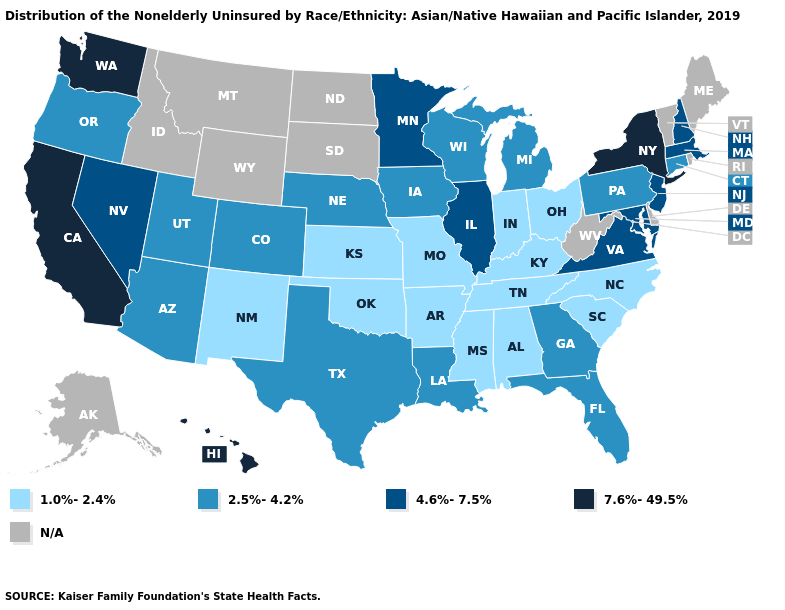Which states have the lowest value in the USA?
Concise answer only. Alabama, Arkansas, Indiana, Kansas, Kentucky, Mississippi, Missouri, New Mexico, North Carolina, Ohio, Oklahoma, South Carolina, Tennessee. Name the states that have a value in the range 7.6%-49.5%?
Quick response, please. California, Hawaii, New York, Washington. Does Nevada have the lowest value in the USA?
Answer briefly. No. Which states hav the highest value in the West?
Keep it brief. California, Hawaii, Washington. Does Hawaii have the highest value in the USA?
Keep it brief. Yes. What is the highest value in states that border Minnesota?
Short answer required. 2.5%-4.2%. Which states have the lowest value in the USA?
Be succinct. Alabama, Arkansas, Indiana, Kansas, Kentucky, Mississippi, Missouri, New Mexico, North Carolina, Ohio, Oklahoma, South Carolina, Tennessee. Which states have the lowest value in the USA?
Keep it brief. Alabama, Arkansas, Indiana, Kansas, Kentucky, Mississippi, Missouri, New Mexico, North Carolina, Ohio, Oklahoma, South Carolina, Tennessee. What is the highest value in the USA?
Answer briefly. 7.6%-49.5%. What is the value of Montana?
Quick response, please. N/A. How many symbols are there in the legend?
Write a very short answer. 5. Name the states that have a value in the range 4.6%-7.5%?
Keep it brief. Illinois, Maryland, Massachusetts, Minnesota, Nevada, New Hampshire, New Jersey, Virginia. Name the states that have a value in the range 2.5%-4.2%?
Be succinct. Arizona, Colorado, Connecticut, Florida, Georgia, Iowa, Louisiana, Michigan, Nebraska, Oregon, Pennsylvania, Texas, Utah, Wisconsin. What is the highest value in the South ?
Give a very brief answer. 4.6%-7.5%. 